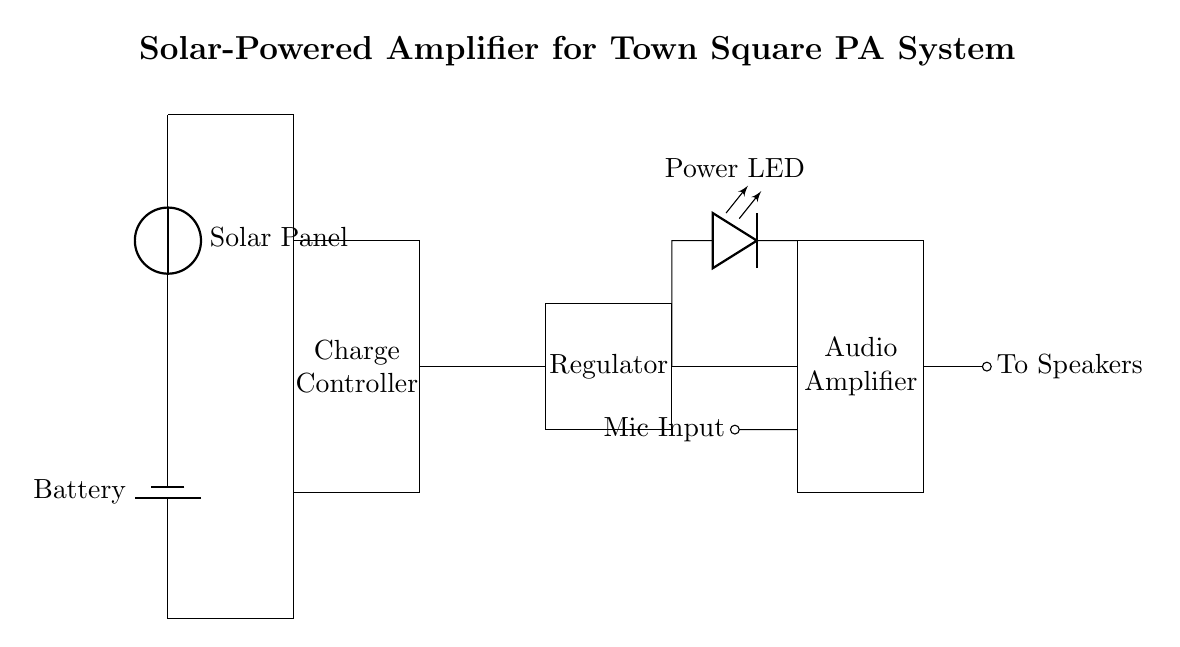What is the role of the solar panel in this circuit? The solar panel generates electric power from sunlight, which is then used to charge the battery and supply power to the amplifier and other components.
Answer: generates power What component regulates the voltage in the circuit? The circuit includes a voltage regulator, which ensures that the voltage supplied to the amplifier is stable and within the appropriate range for its operation.
Answer: voltage regulator How does the microphone input connect to the amplifier? The microphone input is connected directly to the audio amplifier, allowing it to receive audio signals for amplification. This is indicated by the short connection from the microphone to the amplifier's input.
Answer: directly What is the type of power source used for this amplifier circuit? The power source for this amplifier circuit is solar energy, which is captured by the solar panel and stored in the battery.
Answer: solar energy What is the function of the charge controller in this circuit? The charge controller manages the charging process of the battery from the solar panel, preventing overcharging and ensuring safe operation.
Answer: manages charging What is indicated by the LED in the circuit? The LED, labeled as "Power LED," indicates that the circuit is powered and functioning correctly, providing a visual cue for operation.
Answer: indicates power How many main components are there in the circuit? The circuit contains five main components: the solar panel, battery, charge controller, voltage regulator, and audio amplifier.
Answer: five 